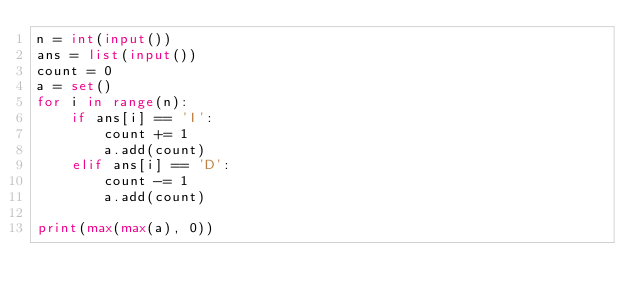<code> <loc_0><loc_0><loc_500><loc_500><_Python_>n = int(input())
ans = list(input())
count = 0
a = set()
for i in range(n):
    if ans[i] == 'I':
        count += 1
        a.add(count)
    elif ans[i] == 'D':
        count -= 1
        a.add(count)

print(max(max(a), 0))</code> 